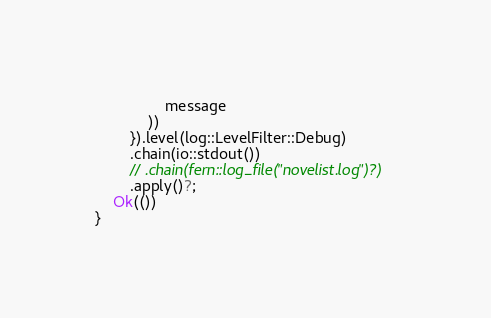Convert code to text. <code><loc_0><loc_0><loc_500><loc_500><_Rust_>                message
            ))
        }).level(log::LevelFilter::Debug)
        .chain(io::stdout())
        // .chain(fern::log_file("novelist.log")?)
        .apply()?;
    Ok(())
}
</code> 